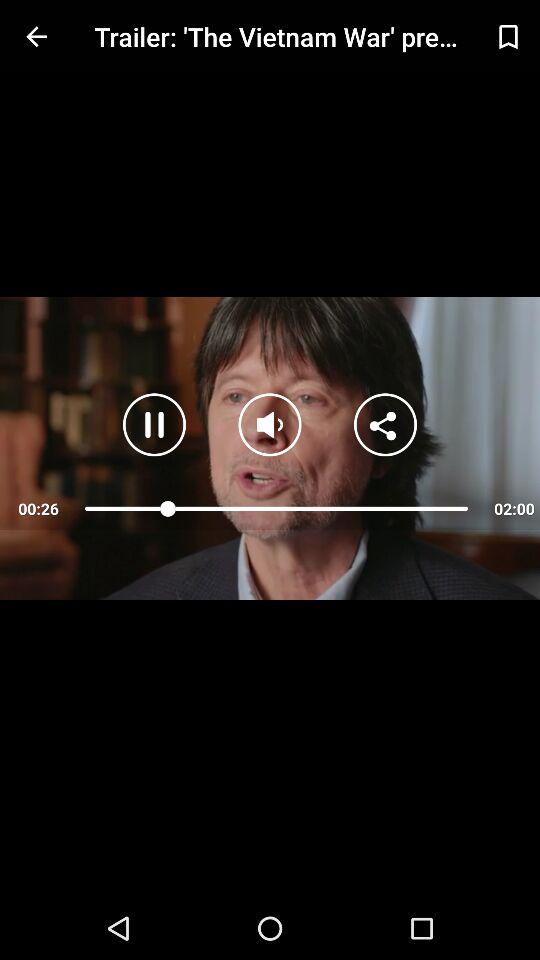What is the total time duration of "The Vietnam War" trailer video? The total time duration of "The Vietnam War" trailer video is 2 minutes. 